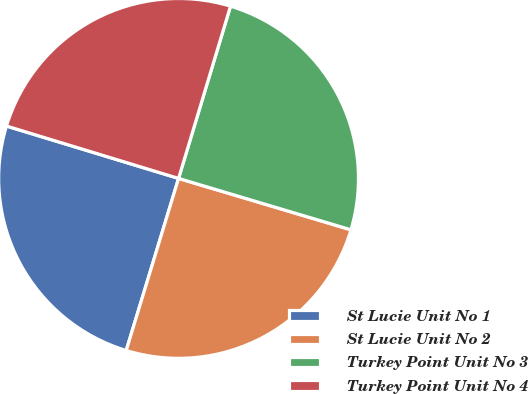Convert chart to OTSL. <chart><loc_0><loc_0><loc_500><loc_500><pie_chart><fcel>St Lucie Unit No 1<fcel>St Lucie Unit No 2<fcel>Turkey Point Unit No 3<fcel>Turkey Point Unit No 4<nl><fcel>25.0%<fcel>25.09%<fcel>24.95%<fcel>24.96%<nl></chart> 